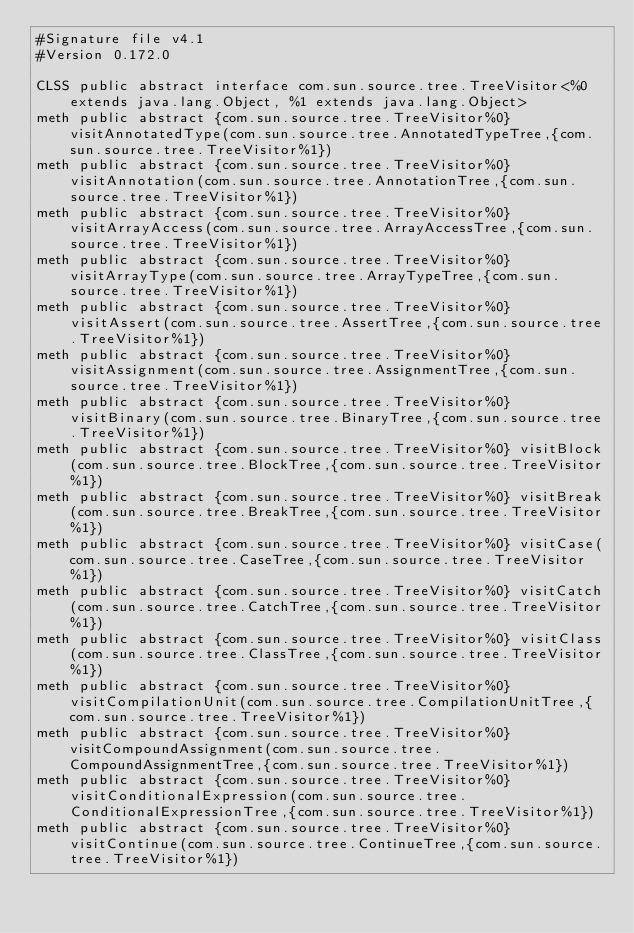<code> <loc_0><loc_0><loc_500><loc_500><_SML_>#Signature file v4.1
#Version 0.172.0

CLSS public abstract interface com.sun.source.tree.TreeVisitor<%0 extends java.lang.Object, %1 extends java.lang.Object>
meth public abstract {com.sun.source.tree.TreeVisitor%0} visitAnnotatedType(com.sun.source.tree.AnnotatedTypeTree,{com.sun.source.tree.TreeVisitor%1})
meth public abstract {com.sun.source.tree.TreeVisitor%0} visitAnnotation(com.sun.source.tree.AnnotationTree,{com.sun.source.tree.TreeVisitor%1})
meth public abstract {com.sun.source.tree.TreeVisitor%0} visitArrayAccess(com.sun.source.tree.ArrayAccessTree,{com.sun.source.tree.TreeVisitor%1})
meth public abstract {com.sun.source.tree.TreeVisitor%0} visitArrayType(com.sun.source.tree.ArrayTypeTree,{com.sun.source.tree.TreeVisitor%1})
meth public abstract {com.sun.source.tree.TreeVisitor%0} visitAssert(com.sun.source.tree.AssertTree,{com.sun.source.tree.TreeVisitor%1})
meth public abstract {com.sun.source.tree.TreeVisitor%0} visitAssignment(com.sun.source.tree.AssignmentTree,{com.sun.source.tree.TreeVisitor%1})
meth public abstract {com.sun.source.tree.TreeVisitor%0} visitBinary(com.sun.source.tree.BinaryTree,{com.sun.source.tree.TreeVisitor%1})
meth public abstract {com.sun.source.tree.TreeVisitor%0} visitBlock(com.sun.source.tree.BlockTree,{com.sun.source.tree.TreeVisitor%1})
meth public abstract {com.sun.source.tree.TreeVisitor%0} visitBreak(com.sun.source.tree.BreakTree,{com.sun.source.tree.TreeVisitor%1})
meth public abstract {com.sun.source.tree.TreeVisitor%0} visitCase(com.sun.source.tree.CaseTree,{com.sun.source.tree.TreeVisitor%1})
meth public abstract {com.sun.source.tree.TreeVisitor%0} visitCatch(com.sun.source.tree.CatchTree,{com.sun.source.tree.TreeVisitor%1})
meth public abstract {com.sun.source.tree.TreeVisitor%0} visitClass(com.sun.source.tree.ClassTree,{com.sun.source.tree.TreeVisitor%1})
meth public abstract {com.sun.source.tree.TreeVisitor%0} visitCompilationUnit(com.sun.source.tree.CompilationUnitTree,{com.sun.source.tree.TreeVisitor%1})
meth public abstract {com.sun.source.tree.TreeVisitor%0} visitCompoundAssignment(com.sun.source.tree.CompoundAssignmentTree,{com.sun.source.tree.TreeVisitor%1})
meth public abstract {com.sun.source.tree.TreeVisitor%0} visitConditionalExpression(com.sun.source.tree.ConditionalExpressionTree,{com.sun.source.tree.TreeVisitor%1})
meth public abstract {com.sun.source.tree.TreeVisitor%0} visitContinue(com.sun.source.tree.ContinueTree,{com.sun.source.tree.TreeVisitor%1})</code> 